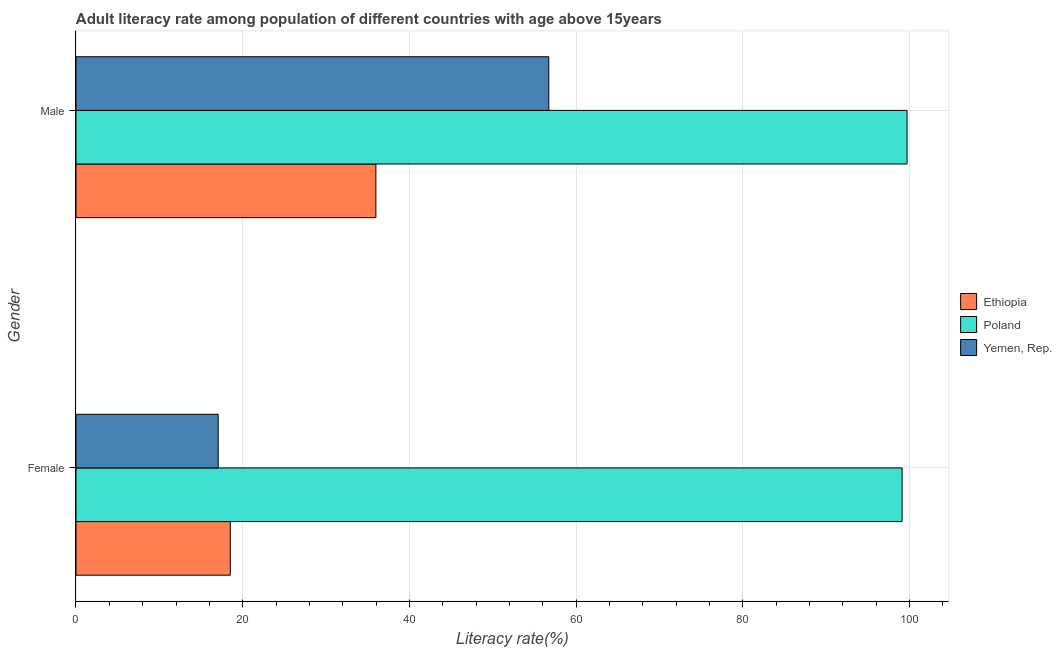How many different coloured bars are there?
Make the answer very short. 3. Are the number of bars per tick equal to the number of legend labels?
Your answer should be compact. Yes. How many bars are there on the 1st tick from the top?
Ensure brevity in your answer.  3. How many bars are there on the 2nd tick from the bottom?
Make the answer very short. 3. What is the label of the 1st group of bars from the top?
Give a very brief answer. Male. What is the female adult literacy rate in Poland?
Your answer should be very brief. 99.12. Across all countries, what is the maximum male adult literacy rate?
Make the answer very short. 99.71. Across all countries, what is the minimum male adult literacy rate?
Your answer should be compact. 35.98. In which country was the female adult literacy rate maximum?
Ensure brevity in your answer.  Poland. In which country was the male adult literacy rate minimum?
Give a very brief answer. Ethiopia. What is the total male adult literacy rate in the graph?
Your answer should be compact. 192.42. What is the difference between the female adult literacy rate in Ethiopia and that in Poland?
Keep it short and to the point. -80.6. What is the difference between the female adult literacy rate in Ethiopia and the male adult literacy rate in Yemen, Rep.?
Give a very brief answer. -38.21. What is the average female adult literacy rate per country?
Your response must be concise. 44.9. What is the difference between the female adult literacy rate and male adult literacy rate in Yemen, Rep.?
Offer a terse response. -39.67. What is the ratio of the male adult literacy rate in Yemen, Rep. to that in Poland?
Provide a succinct answer. 0.57. In how many countries, is the male adult literacy rate greater than the average male adult literacy rate taken over all countries?
Offer a very short reply. 1. What does the 1st bar from the top in Male represents?
Offer a very short reply. Yemen, Rep. What does the 3rd bar from the bottom in Female represents?
Your answer should be very brief. Yemen, Rep. How many countries are there in the graph?
Give a very brief answer. 3. How many legend labels are there?
Make the answer very short. 3. What is the title of the graph?
Provide a short and direct response. Adult literacy rate among population of different countries with age above 15years. What is the label or title of the X-axis?
Provide a short and direct response. Literacy rate(%). What is the Literacy rate(%) in Ethiopia in Female?
Provide a succinct answer. 18.51. What is the Literacy rate(%) of Poland in Female?
Provide a short and direct response. 99.12. What is the Literacy rate(%) in Yemen, Rep. in Female?
Your response must be concise. 17.06. What is the Literacy rate(%) in Ethiopia in Male?
Give a very brief answer. 35.98. What is the Literacy rate(%) of Poland in Male?
Keep it short and to the point. 99.71. What is the Literacy rate(%) of Yemen, Rep. in Male?
Ensure brevity in your answer.  56.72. Across all Gender, what is the maximum Literacy rate(%) in Ethiopia?
Offer a very short reply. 35.98. Across all Gender, what is the maximum Literacy rate(%) of Poland?
Provide a succinct answer. 99.71. Across all Gender, what is the maximum Literacy rate(%) in Yemen, Rep.?
Keep it short and to the point. 56.72. Across all Gender, what is the minimum Literacy rate(%) in Ethiopia?
Your answer should be very brief. 18.51. Across all Gender, what is the minimum Literacy rate(%) in Poland?
Ensure brevity in your answer.  99.12. Across all Gender, what is the minimum Literacy rate(%) of Yemen, Rep.?
Make the answer very short. 17.06. What is the total Literacy rate(%) of Ethiopia in the graph?
Offer a very short reply. 54.5. What is the total Literacy rate(%) in Poland in the graph?
Offer a terse response. 198.83. What is the total Literacy rate(%) of Yemen, Rep. in the graph?
Provide a short and direct response. 73.78. What is the difference between the Literacy rate(%) in Ethiopia in Female and that in Male?
Make the answer very short. -17.47. What is the difference between the Literacy rate(%) of Poland in Female and that in Male?
Your response must be concise. -0.59. What is the difference between the Literacy rate(%) in Yemen, Rep. in Female and that in Male?
Offer a terse response. -39.67. What is the difference between the Literacy rate(%) of Ethiopia in Female and the Literacy rate(%) of Poland in Male?
Your answer should be very brief. -81.2. What is the difference between the Literacy rate(%) in Ethiopia in Female and the Literacy rate(%) in Yemen, Rep. in Male?
Offer a very short reply. -38.21. What is the difference between the Literacy rate(%) in Poland in Female and the Literacy rate(%) in Yemen, Rep. in Male?
Offer a terse response. 42.39. What is the average Literacy rate(%) of Ethiopia per Gender?
Offer a terse response. 27.25. What is the average Literacy rate(%) of Poland per Gender?
Your response must be concise. 99.42. What is the average Literacy rate(%) of Yemen, Rep. per Gender?
Provide a short and direct response. 36.89. What is the difference between the Literacy rate(%) in Ethiopia and Literacy rate(%) in Poland in Female?
Make the answer very short. -80.6. What is the difference between the Literacy rate(%) of Ethiopia and Literacy rate(%) of Yemen, Rep. in Female?
Keep it short and to the point. 1.46. What is the difference between the Literacy rate(%) in Poland and Literacy rate(%) in Yemen, Rep. in Female?
Ensure brevity in your answer.  82.06. What is the difference between the Literacy rate(%) of Ethiopia and Literacy rate(%) of Poland in Male?
Give a very brief answer. -63.73. What is the difference between the Literacy rate(%) of Ethiopia and Literacy rate(%) of Yemen, Rep. in Male?
Make the answer very short. -20.74. What is the difference between the Literacy rate(%) of Poland and Literacy rate(%) of Yemen, Rep. in Male?
Your response must be concise. 42.99. What is the ratio of the Literacy rate(%) in Ethiopia in Female to that in Male?
Offer a terse response. 0.51. What is the ratio of the Literacy rate(%) of Poland in Female to that in Male?
Give a very brief answer. 0.99. What is the ratio of the Literacy rate(%) in Yemen, Rep. in Female to that in Male?
Your response must be concise. 0.3. What is the difference between the highest and the second highest Literacy rate(%) of Ethiopia?
Provide a succinct answer. 17.47. What is the difference between the highest and the second highest Literacy rate(%) of Poland?
Ensure brevity in your answer.  0.59. What is the difference between the highest and the second highest Literacy rate(%) of Yemen, Rep.?
Ensure brevity in your answer.  39.67. What is the difference between the highest and the lowest Literacy rate(%) of Ethiopia?
Keep it short and to the point. 17.47. What is the difference between the highest and the lowest Literacy rate(%) of Poland?
Your answer should be very brief. 0.59. What is the difference between the highest and the lowest Literacy rate(%) in Yemen, Rep.?
Keep it short and to the point. 39.67. 